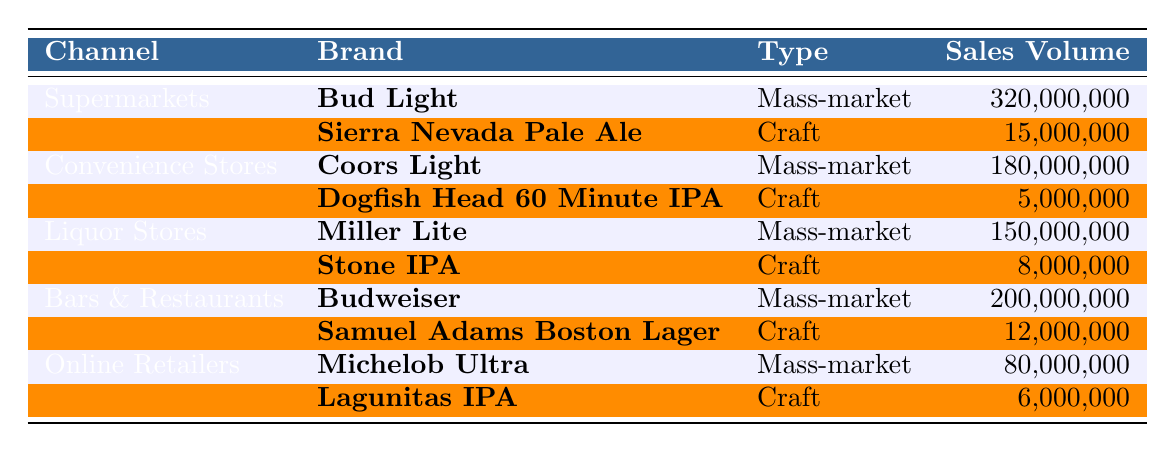What is the sales volume of Bud Light in supermarkets? The sales volume of Bud Light in supermarkets is listed directly in the table as 320,000,000.
Answer: 320,000,000 How much did Coors Light sell in convenience stores? The sales volume for Coors Light in convenience stores is directly found in the table, which shows it as 180,000,000.
Answer: 180,000,000 Which retail channel generated the highest sales volume for mass-market beers? By comparing the sales volumes for mass-market beers in different channels, Budweiser in Bars & Restaurants had the highest sales at 200,000,000.
Answer: Bars & Restaurants What is the total sales volume of craft beers across all retail channels? The sales volumes of craft beers are: Sierra Nevada Pale Ale (15,000,000), Dogfish Head 60 Minute IPA (5,000,000), Stone IPA (8,000,000), Samuel Adams Boston Lager (12,000,000), and Lagunitas IPA (6,000,000). Adding these values gives a total of 46,000,000.
Answer: 46,000,000 In liquor stores, how does the sales volume of Miller Lite compare to Stone IPA? Miller Lite has a sales volume of 150,000,000 while Stone IPA has 8,000,000. The difference is calculated as 150,000,000 - 8,000,000 = 142,000,000, indicating Miller Lite sells significantly more.
Answer: 142,000,000 Which mass-market beer had the lowest sales volume? Looking through the sales volumes of mass-market beers, Michelob Ultra has the lowest sales at 80,000,000 compared to others like Bud Light, Coors Light, and Miller Lite.
Answer: Michelob Ultra Is the sales volume of craft beers in supermarkets greater than that in convenience stores? In supermarkets, Sierra Nevada Pale Ale sold 15,000,000, while in convenience stores, Dogfish Head 60 Minute IPA sold 5,000,000. Since 15,000,000 is greater than 5,000,000, the statement is true.
Answer: Yes What is the percentage of sales volume for craft beer compared to mass-market beer in online retailers? The sales volume for Michelob Ultra (mass-market) is 80,000,000 while for Lagunitas IPA (craft) it is 6,000,000. To find the percentage of craft beer sales, use the formula (6,000,000 / 80,000,000) * 100, which equals 7.5%.
Answer: 7.5% Which channel has the highest combined sales volume for both mass-market and craft beers? By summing the sales for each channel: Supermarkets (320,000,000 + 15,000,000 = 335,000,000), Convenience Stores (180,000,000 + 5,000,000 = 185,000,000), Liquor Stores (150,000,000 + 8,000,000 = 158,000,000), Bars & Restaurants (200,000,000 + 12,000,000 = 212,000,000), Online Retailers (80,000,000 + 6,000,000 = 86,000,000). The highest is Supermarkets with 335,000,000.
Answer: Supermarkets Which retail channel contributes the least to mass-market beer sales? Comparing the sales volume figures for mass-market beers in all channels, the online retailers with 80,000,000 contribute the least compared to Bars & Restaurants (200,000,000), Liquor Stores (150,000,000), and Convenience Stores (180,000,000).
Answer: Online Retailers 